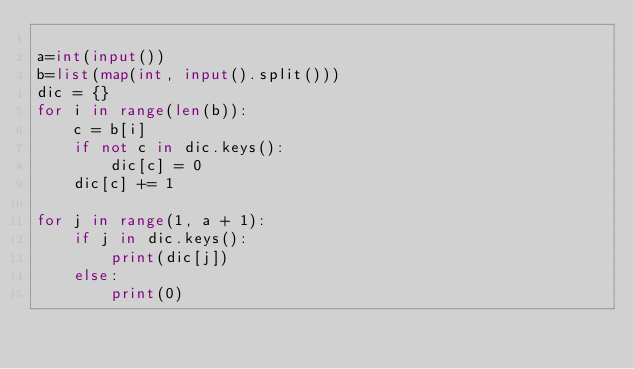Convert code to text. <code><loc_0><loc_0><loc_500><loc_500><_Python_>
a=int(input())
b=list(map(int, input().split()))
dic = {}
for i in range(len(b)):
    c = b[i] 
    if not c in dic.keys():
        dic[c] = 0
    dic[c] += 1

for j in range(1, a + 1):
    if j in dic.keys():
        print(dic[j])
    else:
        print(0)
</code> 